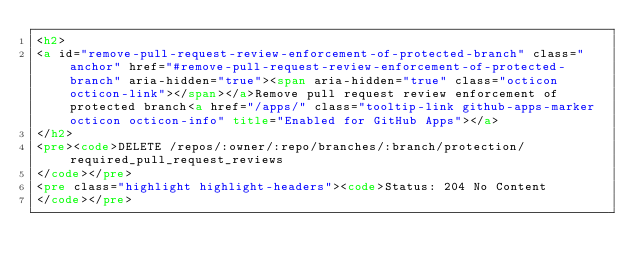Convert code to text. <code><loc_0><loc_0><loc_500><loc_500><_HTML_><h2>
<a id="remove-pull-request-review-enforcement-of-protected-branch" class="anchor" href="#remove-pull-request-review-enforcement-of-protected-branch" aria-hidden="true"><span aria-hidden="true" class="octicon octicon-link"></span></a>Remove pull request review enforcement of protected branch<a href="/apps/" class="tooltip-link github-apps-marker octicon octicon-info" title="Enabled for GitHub Apps"></a>
</h2>
<pre><code>DELETE /repos/:owner/:repo/branches/:branch/protection/required_pull_request_reviews
</code></pre>
<pre class="highlight highlight-headers"><code>Status: 204 No Content
</code></pre></code> 